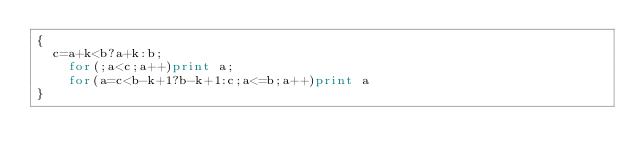Convert code to text. <code><loc_0><loc_0><loc_500><loc_500><_Awk_>{
	c=a+k<b?a+k:b;
    for(;a<c;a++)print a;
    for(a=c<b-k+1?b-k+1:c;a<=b;a++)print a
}</code> 